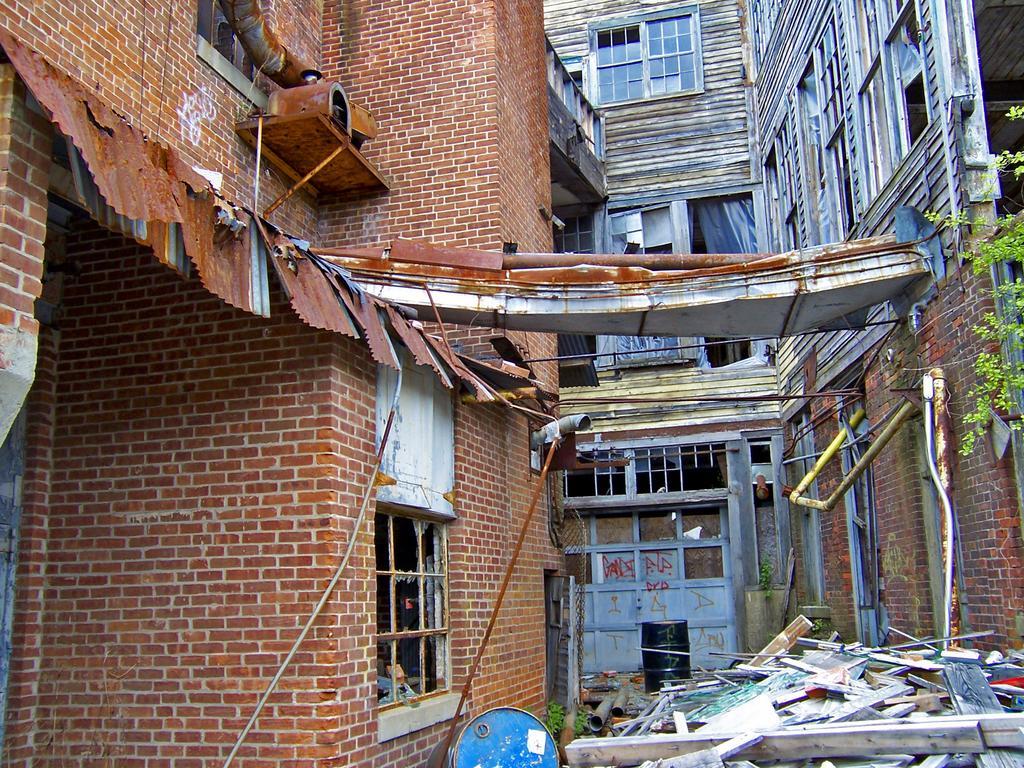How would you summarize this image in a sentence or two? On the left side, there is a building. which is built with bricks and is having windows. On the right side, there are wood items and other objects, near a plant and other building. Which is having glass windows. 